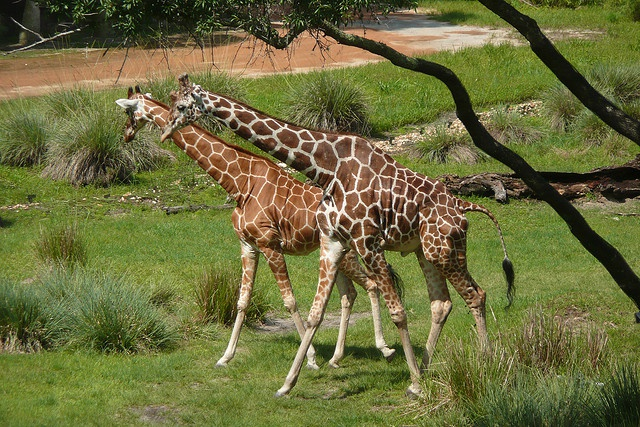Describe the objects in this image and their specific colors. I can see giraffe in black, olive, and maroon tones and giraffe in black, gray, brown, olive, and maroon tones in this image. 